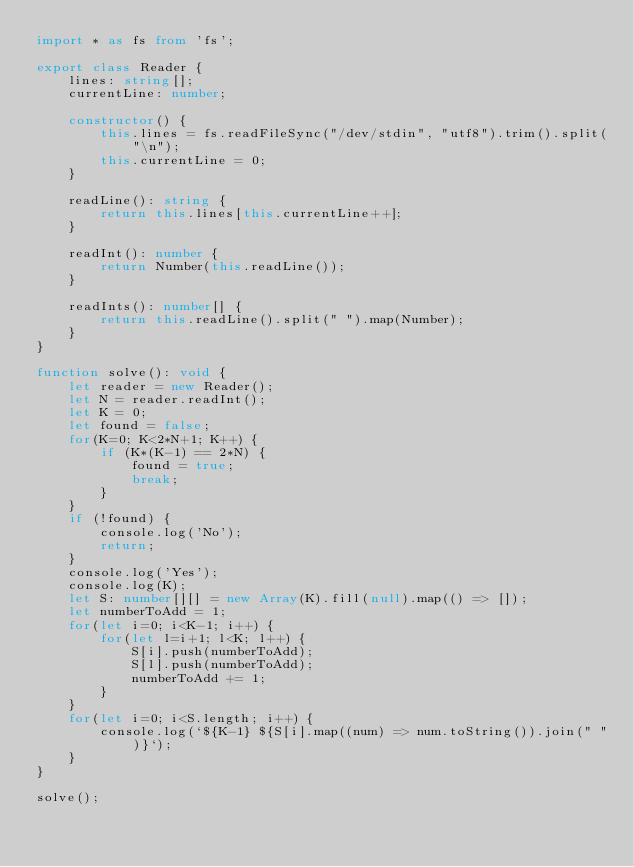Convert code to text. <code><loc_0><loc_0><loc_500><loc_500><_TypeScript_>import * as fs from 'fs';

export class Reader {
    lines: string[];
    currentLine: number;

    constructor() {
        this.lines = fs.readFileSync("/dev/stdin", "utf8").trim().split("\n");
        this.currentLine = 0;
    }

    readLine(): string {
        return this.lines[this.currentLine++];
    }

    readInt(): number {
        return Number(this.readLine());
    }

    readInts(): number[] {
        return this.readLine().split(" ").map(Number);
    }
}

function solve(): void {
	let reader = new Reader();
	let N = reader.readInt();
	let K = 0;
	let found = false;
	for(K=0; K<2*N+1; K++) {
		if (K*(K-1) == 2*N) {
			found = true;
			break;
		}
	}
	if (!found) {
		console.log('No');
		return;
	}
	console.log('Yes');
	console.log(K);
	let S: number[][] = new Array(K).fill(null).map(() => []);
	let numberToAdd = 1;
	for(let i=0; i<K-1; i++) {
		for(let l=i+1; l<K; l++) {
			S[i].push(numberToAdd);
			S[l].push(numberToAdd);
			numberToAdd += 1;
		}
	}
	for(let i=0; i<S.length; i++) {
		console.log(`${K-1} ${S[i].map((num) => num.toString()).join(" ")}`);
	}
}

solve();
</code> 